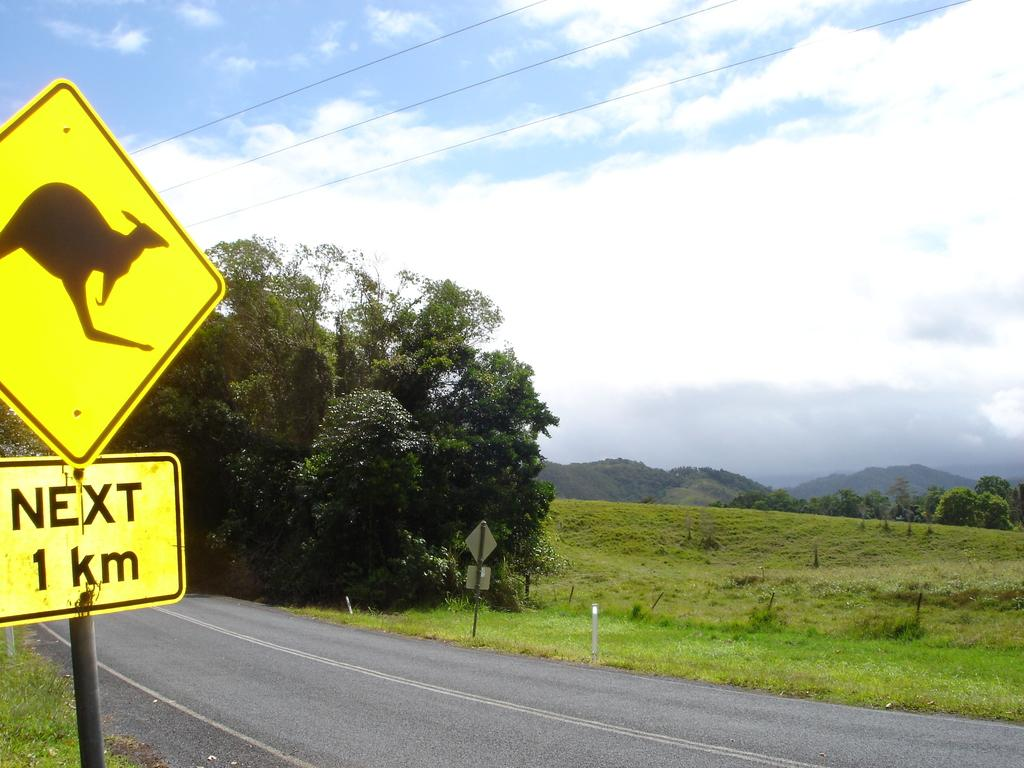Provide a one-sentence caption for the provided image. Kangaroo crossing signs are posted along side this road. 